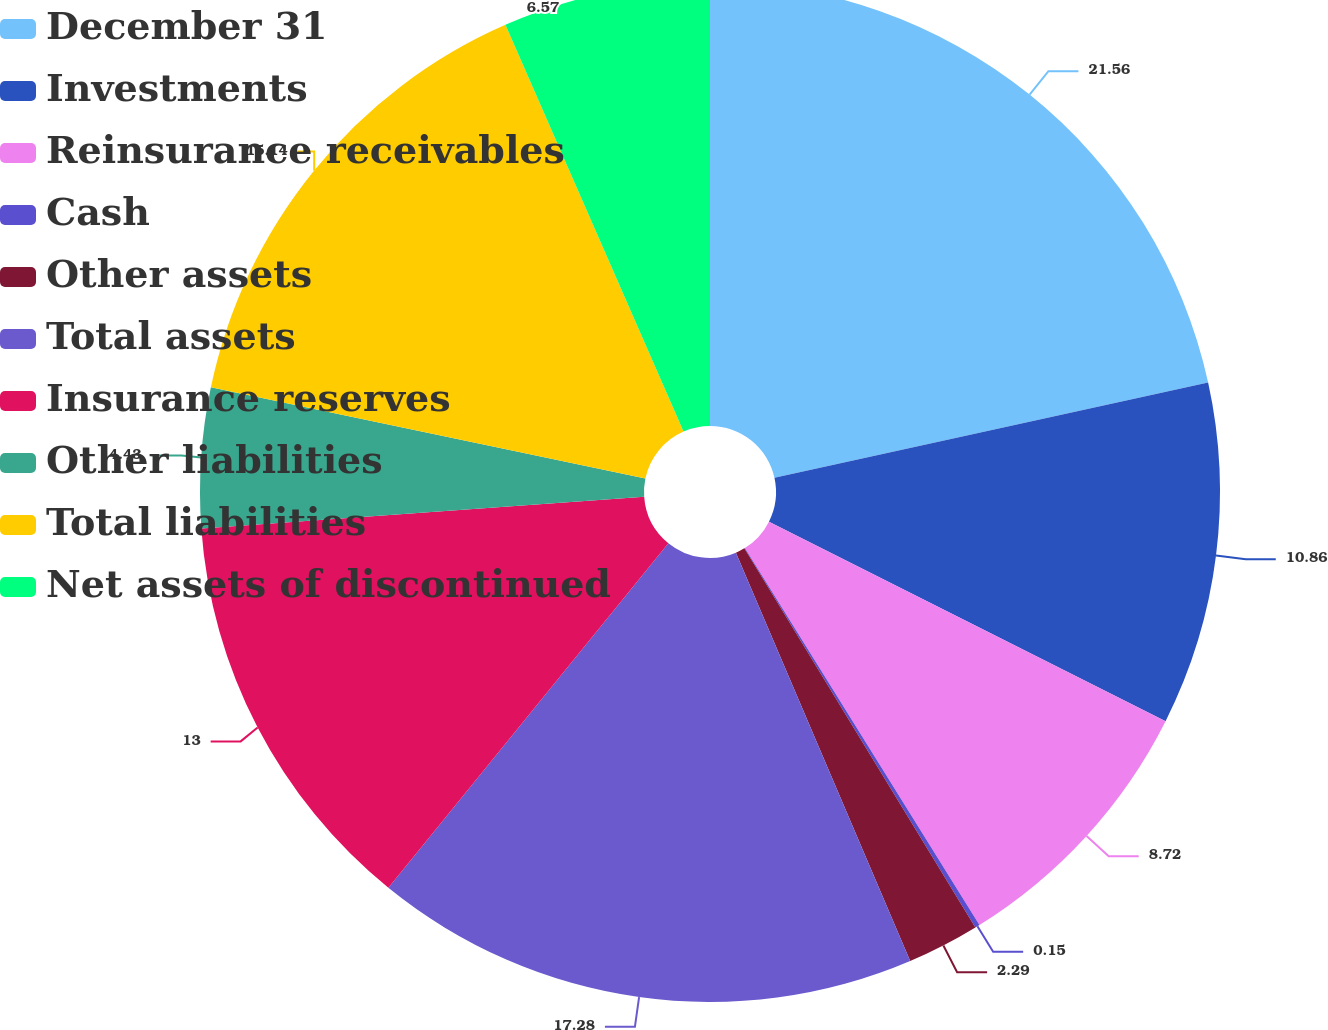<chart> <loc_0><loc_0><loc_500><loc_500><pie_chart><fcel>December 31<fcel>Investments<fcel>Reinsurance receivables<fcel>Cash<fcel>Other assets<fcel>Total assets<fcel>Insurance reserves<fcel>Other liabilities<fcel>Total liabilities<fcel>Net assets of discontinued<nl><fcel>21.56%<fcel>10.86%<fcel>8.72%<fcel>0.15%<fcel>2.29%<fcel>17.28%<fcel>13.0%<fcel>4.43%<fcel>15.14%<fcel>6.57%<nl></chart> 